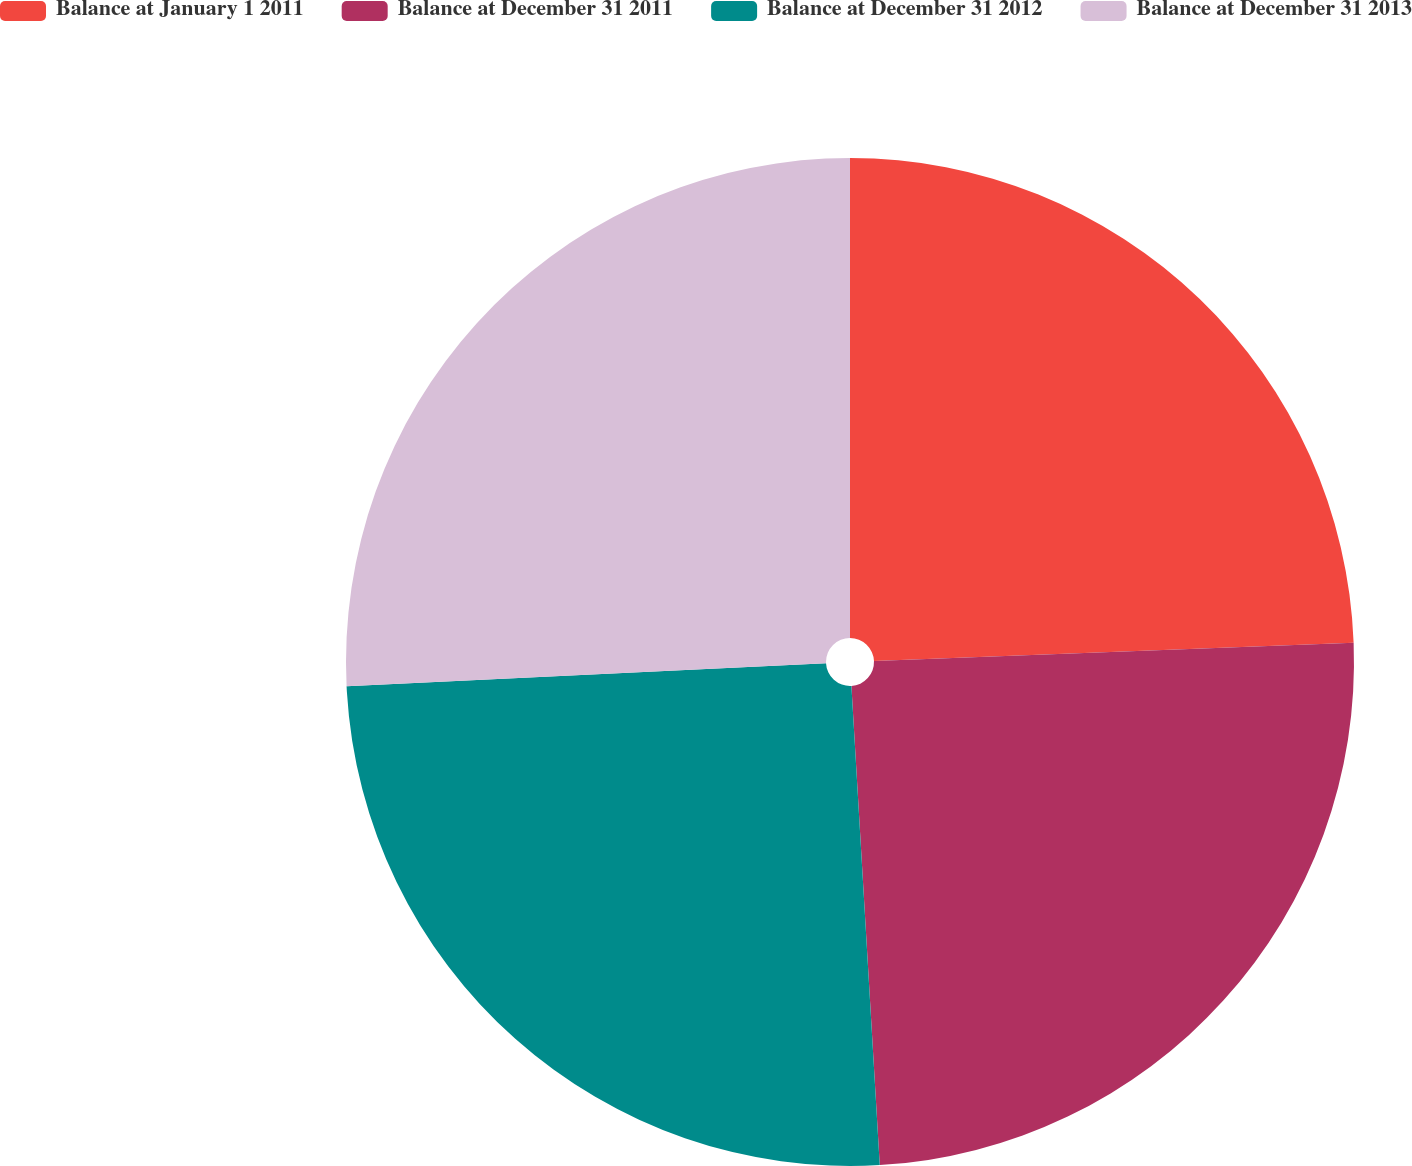Convert chart. <chart><loc_0><loc_0><loc_500><loc_500><pie_chart><fcel>Balance at January 1 2011<fcel>Balance at December 31 2011<fcel>Balance at December 31 2012<fcel>Balance at December 31 2013<nl><fcel>24.39%<fcel>24.67%<fcel>25.17%<fcel>25.77%<nl></chart> 